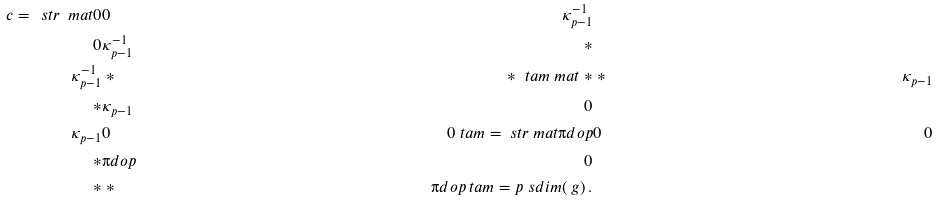Convert formula to latex. <formula><loc_0><loc_0><loc_500><loc_500>c = \ s t r \ m a t 0 & 0 & \kappa _ { p - 1 } ^ { - 1 } \\ 0 & \kappa _ { p - 1 } ^ { - 1 } & \ast \\ \kappa _ { p - 1 } ^ { - 1 } & \ast & \ast \ t a m \ m a t \ast & \ast & \kappa _ { p - 1 } \\ \ast & \kappa _ { p - 1 } & 0 \\ \kappa _ { p - 1 } & 0 & 0 \ t a m = \ s t r \ m a t \i d o p & 0 & 0 \\ \ast & \i d o p & 0 \\ \ast & \ast & \i d o p \ t a m = p \ s d i m ( \ g ) \, .</formula> 